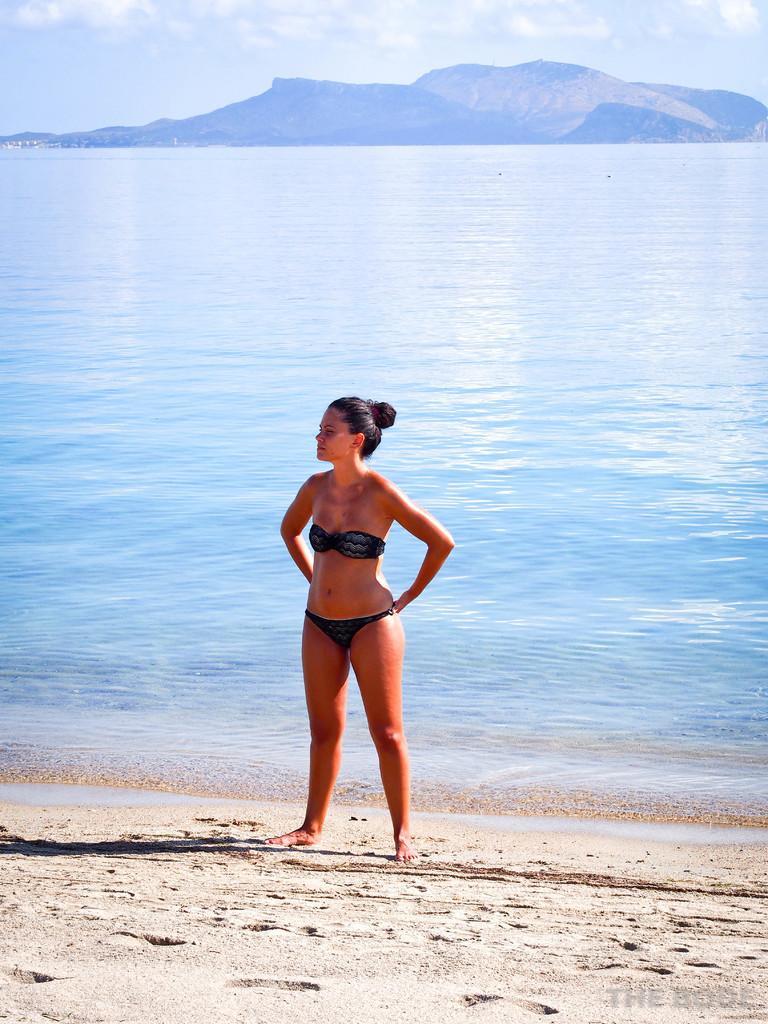Can you describe this image briefly? In this picture we can see a woman standing on the sand. Behind the woman, there is the sea. At the top of the image, there are hills and the sky. 